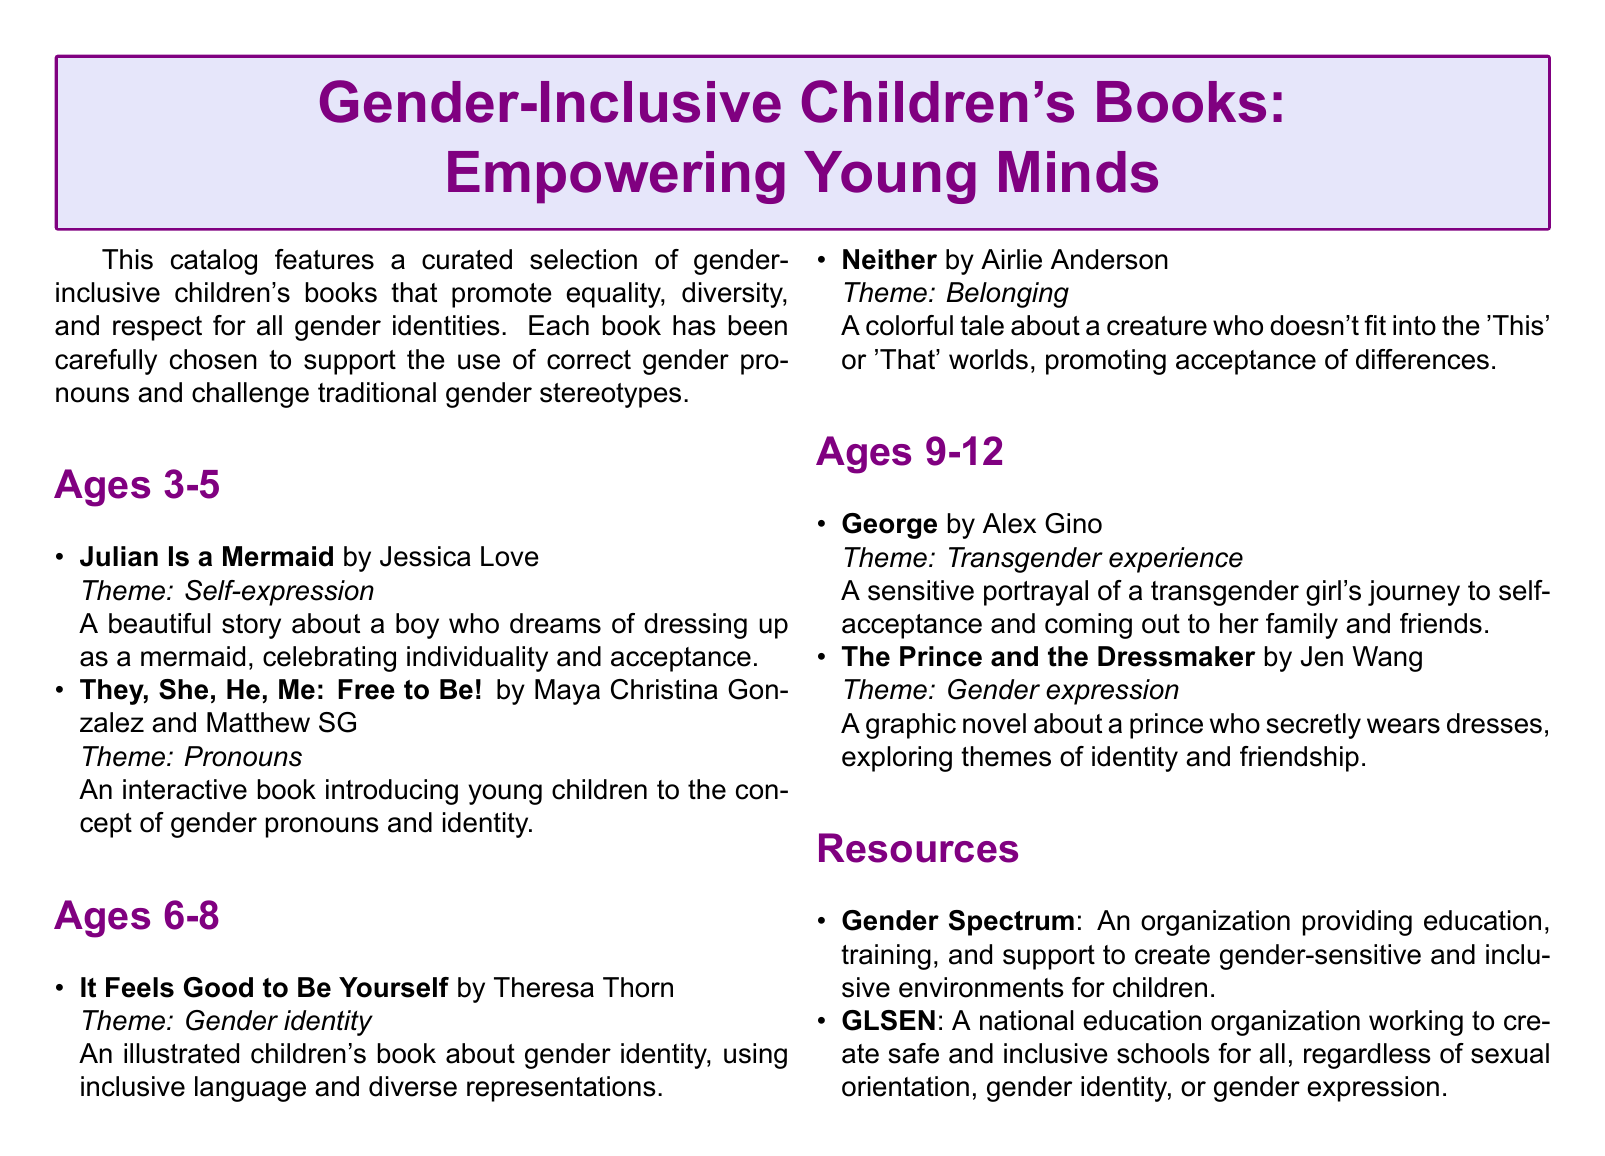What age group is the book "Julian Is a Mermaid" intended for? The age group for "Julian Is a Mermaid" is specified in the catalog, which indicates it is suitable for ages 3-5.
Answer: Ages 3-5 What theme does the book "It Feels Good to Be Yourself" focus on? The theme for "It Feels Good to Be Yourself" is mentioned as gender identity in the catalog.
Answer: Gender identity Who is the author of "Neither"? The author of "Neither" is identified in the catalog, which confirms it is Airlie Anderson.
Answer: Airlie Anderson How many books are listed for ages 9-12? The catalog enumerates the books listed for ages 9-12, indicating there are two books.
Answer: 2 What resource is provided to create gender-sensitive environments? The resource listed for creating gender-sensitive environments is Gender Spectrum, as stated in the catalog.
Answer: Gender Spectrum What type of book is "The Prince and the Dressmaker"? The catalog describes "The Prince and the Dressmaker" as a graphic novel.
Answer: Graphic novel Which book focuses on the concept of gender pronouns? The book that focuses on gender pronouns is "They, She, He, Me: Free to Be!" as noted in the document.
Answer: They, She, He, Me: Free to Be! What organization works to create safe schools for all? The catalog specifies GLSEN as the organization that works on creating safe schools regardless of sexual orientation or gender identity.
Answer: GLSEN 